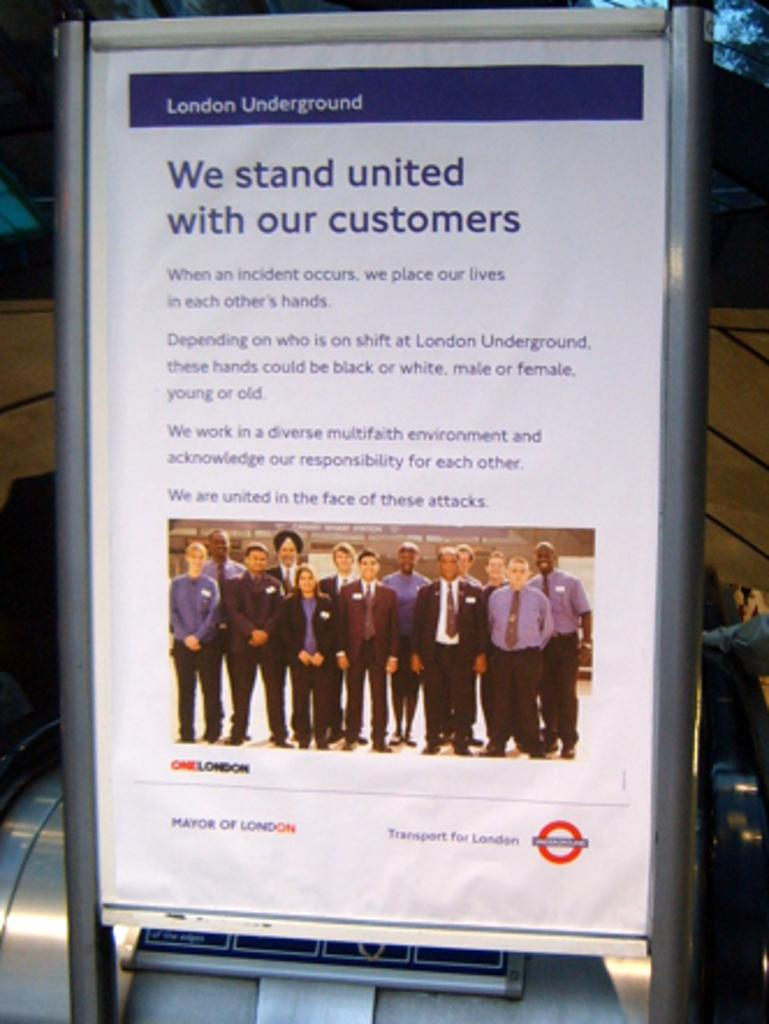<image>
Present a compact description of the photo's key features. A London Underground sign on a metal stand that says "We stand unite without customers". 